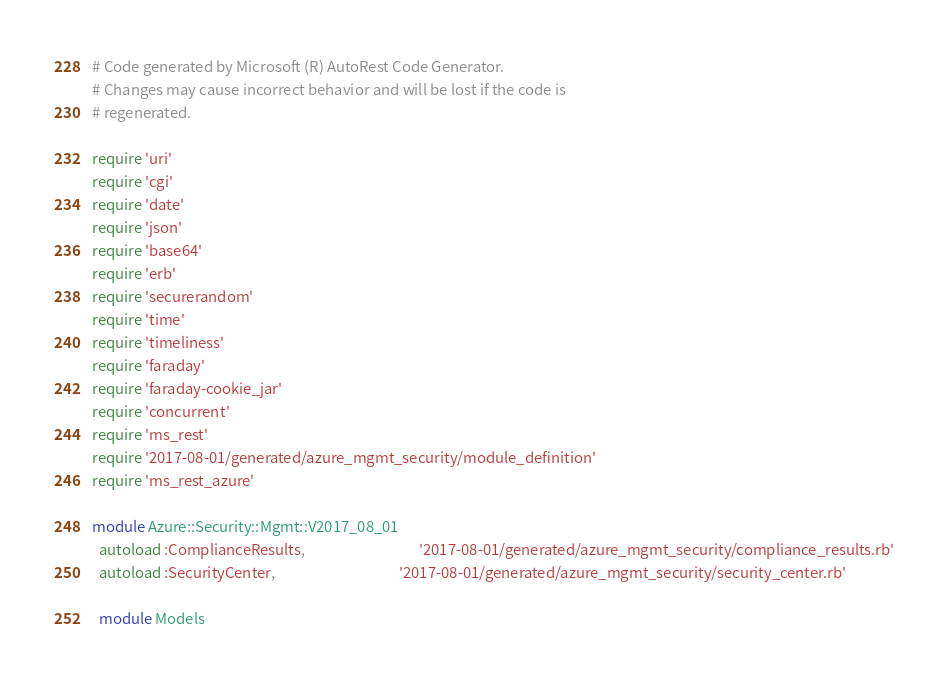<code> <loc_0><loc_0><loc_500><loc_500><_Ruby_># Code generated by Microsoft (R) AutoRest Code Generator.
# Changes may cause incorrect behavior and will be lost if the code is
# regenerated.

require 'uri'
require 'cgi'
require 'date'
require 'json'
require 'base64'
require 'erb'
require 'securerandom'
require 'time'
require 'timeliness'
require 'faraday'
require 'faraday-cookie_jar'
require 'concurrent'
require 'ms_rest'
require '2017-08-01/generated/azure_mgmt_security/module_definition'
require 'ms_rest_azure'

module Azure::Security::Mgmt::V2017_08_01
  autoload :ComplianceResults,                                  '2017-08-01/generated/azure_mgmt_security/compliance_results.rb'
  autoload :SecurityCenter,                                     '2017-08-01/generated/azure_mgmt_security/security_center.rb'

  module Models</code> 